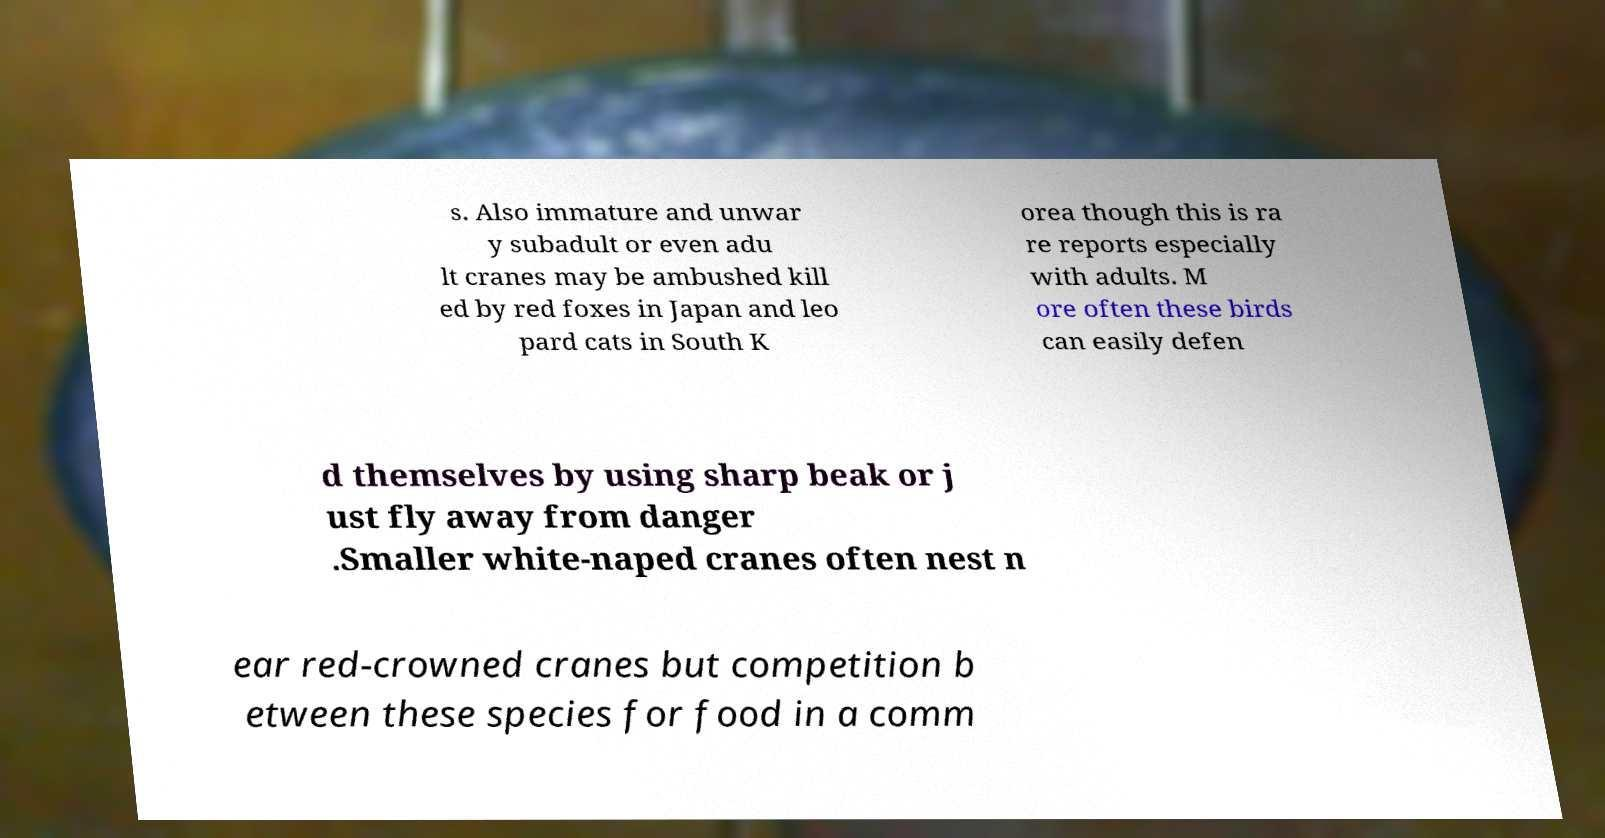Can you read and provide the text displayed in the image?This photo seems to have some interesting text. Can you extract and type it out for me? s. Also immature and unwar y subadult or even adu lt cranes may be ambushed kill ed by red foxes in Japan and leo pard cats in South K orea though this is ra re reports especially with adults. M ore often these birds can easily defen d themselves by using sharp beak or j ust fly away from danger .Smaller white-naped cranes often nest n ear red-crowned cranes but competition b etween these species for food in a comm 